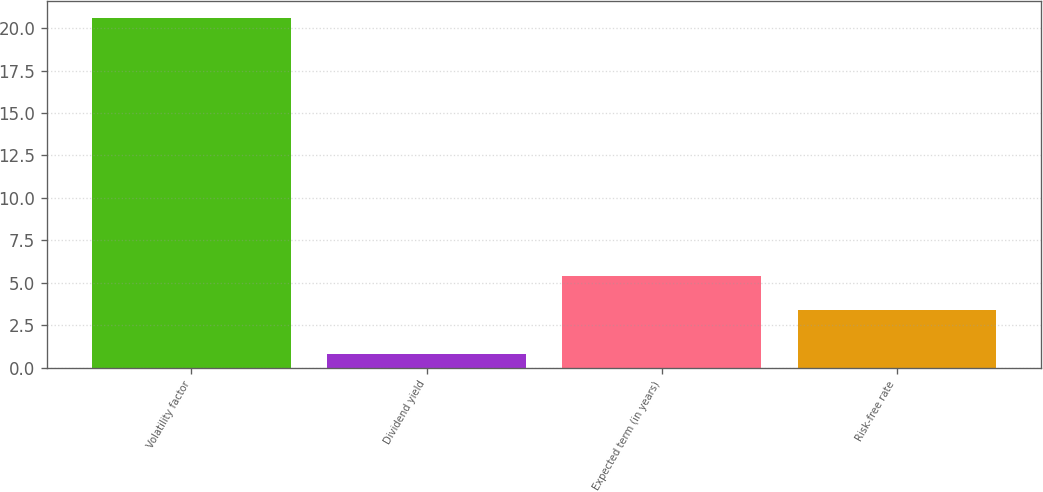Convert chart to OTSL. <chart><loc_0><loc_0><loc_500><loc_500><bar_chart><fcel>Volatility factor<fcel>Dividend yield<fcel>Expected term (in years)<fcel>Risk-free rate<nl><fcel>20.6<fcel>0.8<fcel>5.38<fcel>3.4<nl></chart> 